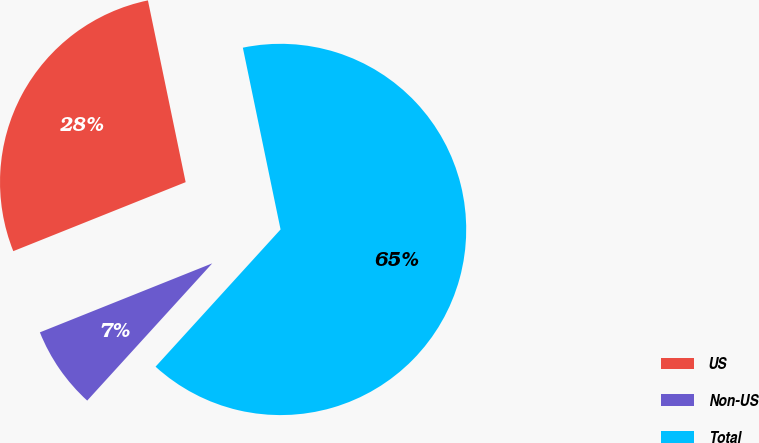<chart> <loc_0><loc_0><loc_500><loc_500><pie_chart><fcel>US<fcel>Non-US<fcel>Total<nl><fcel>27.8%<fcel>7.18%<fcel>65.01%<nl></chart> 